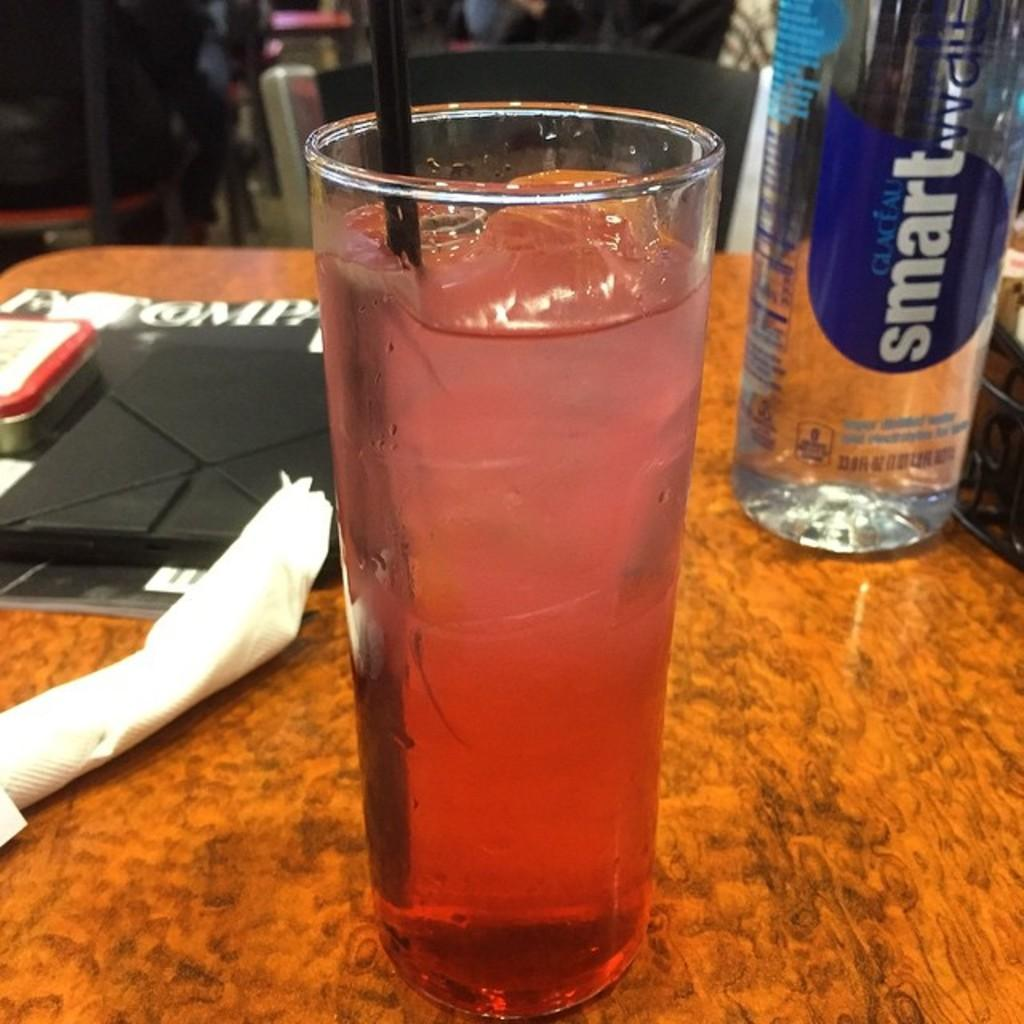What is contained in the glass that is visible in the image? There is a glass with liquid in the image. What other beverage container can be seen in the image? There is a water bottle on the table in the image. How does the corn contribute to the pollution in the image? There is no corn present in the image, so it cannot contribute to any pollution. 